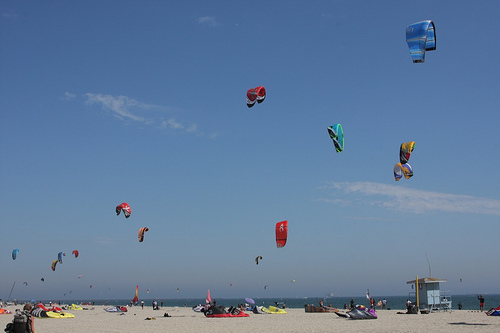<image>Which direction is the wind blowing? I don't know which direction the wind is blowing, there are multiple possibilities like 'west', 'right', 'to east', 'east', 'up'. Which direction is the wind blowing? I'm not sure which direction the wind is blowing. It can be seen as west, east or up. 